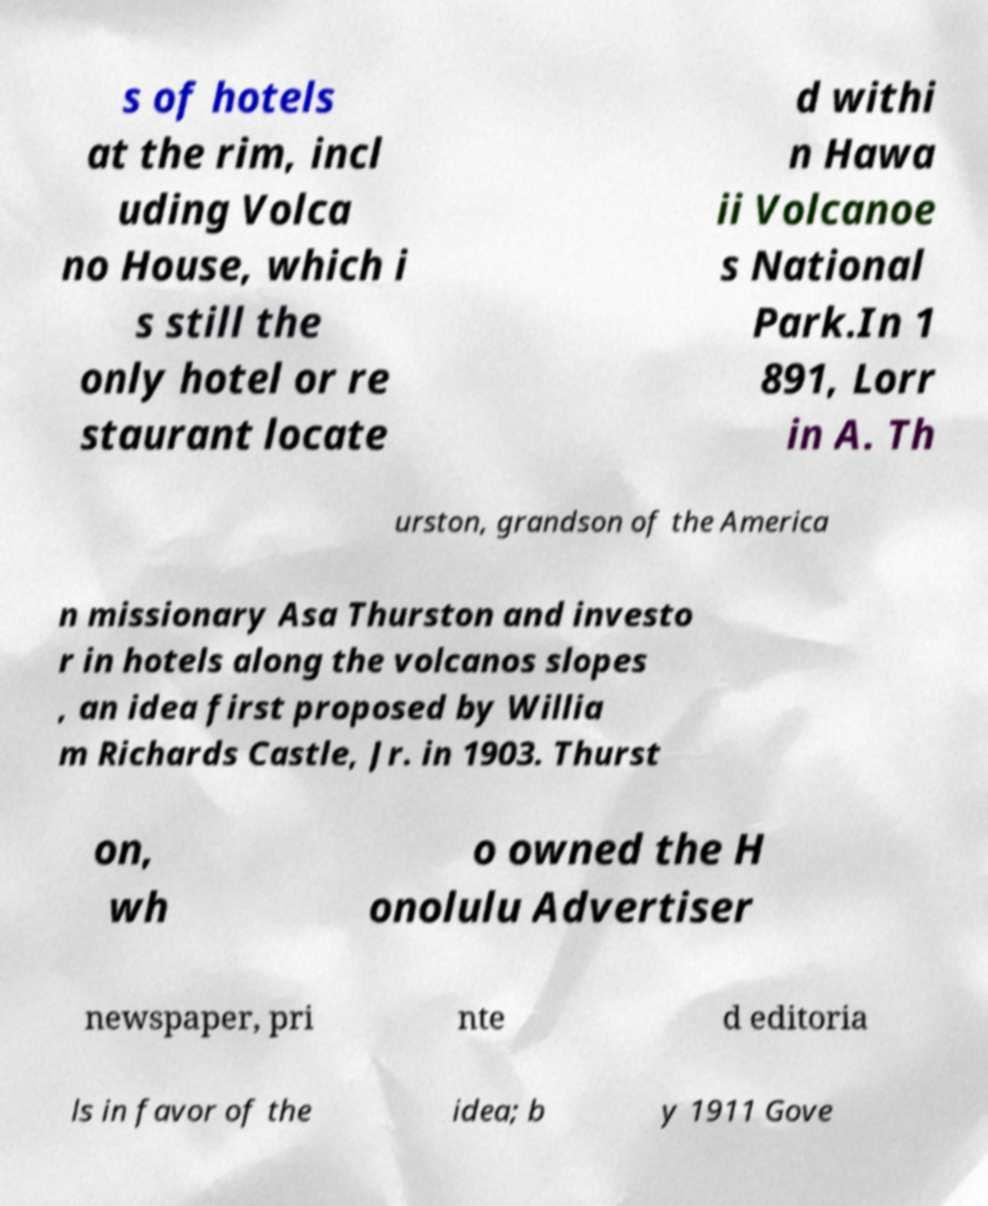There's text embedded in this image that I need extracted. Can you transcribe it verbatim? s of hotels at the rim, incl uding Volca no House, which i s still the only hotel or re staurant locate d withi n Hawa ii Volcanoe s National Park.In 1 891, Lorr in A. Th urston, grandson of the America n missionary Asa Thurston and investo r in hotels along the volcanos slopes , an idea first proposed by Willia m Richards Castle, Jr. in 1903. Thurst on, wh o owned the H onolulu Advertiser newspaper, pri nte d editoria ls in favor of the idea; b y 1911 Gove 